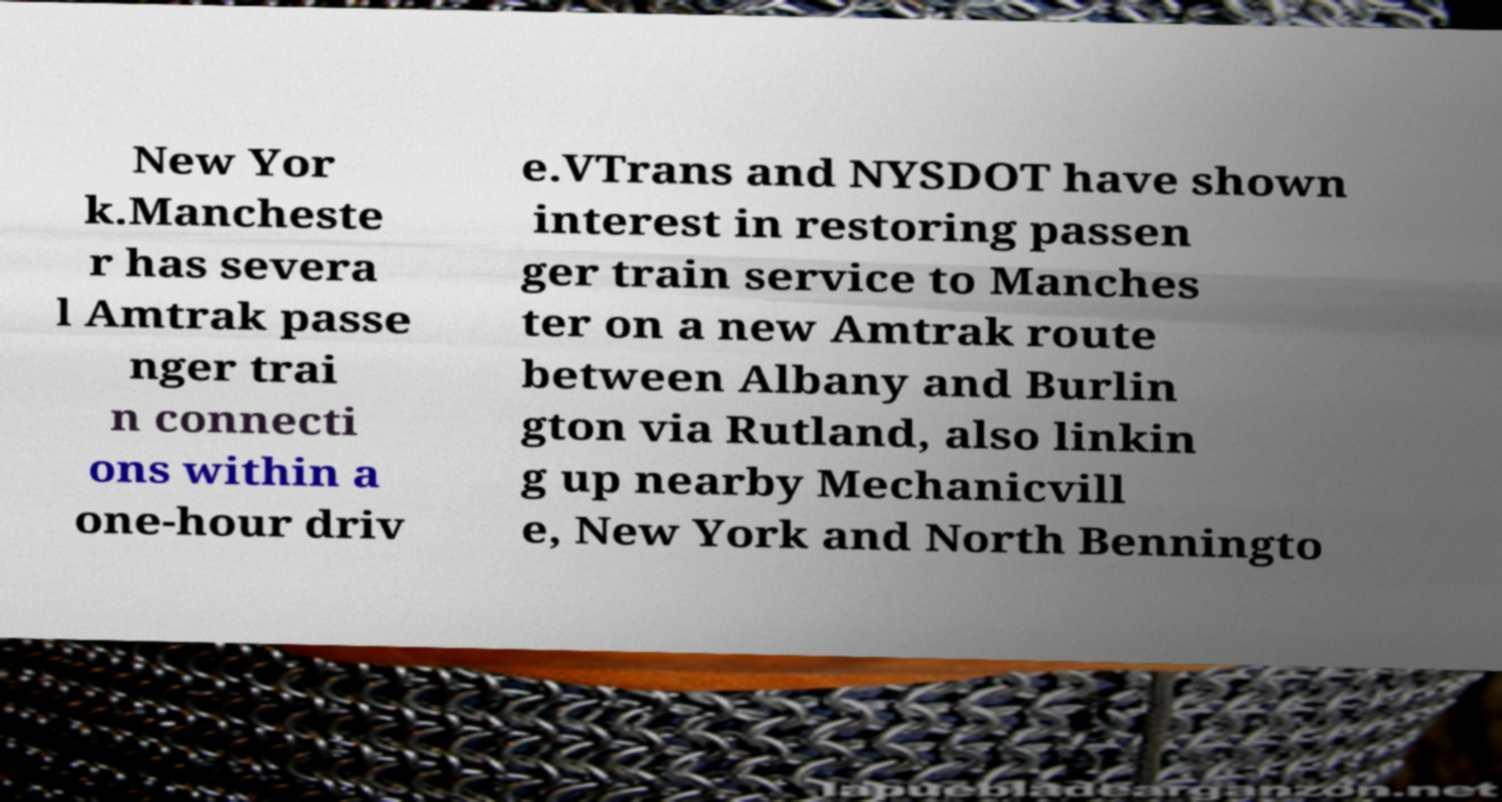Could you assist in decoding the text presented in this image and type it out clearly? New Yor k.Mancheste r has severa l Amtrak passe nger trai n connecti ons within a one-hour driv e.VTrans and NYSDOT have shown interest in restoring passen ger train service to Manches ter on a new Amtrak route between Albany and Burlin gton via Rutland, also linkin g up nearby Mechanicvill e, New York and North Benningto 